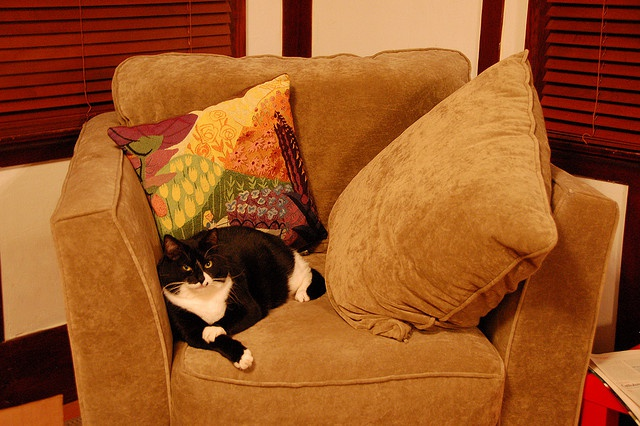Describe the objects in this image and their specific colors. I can see couch in red, maroon, and orange tones, chair in red, maroon, and orange tones, and cat in maroon, black, and tan tones in this image. 